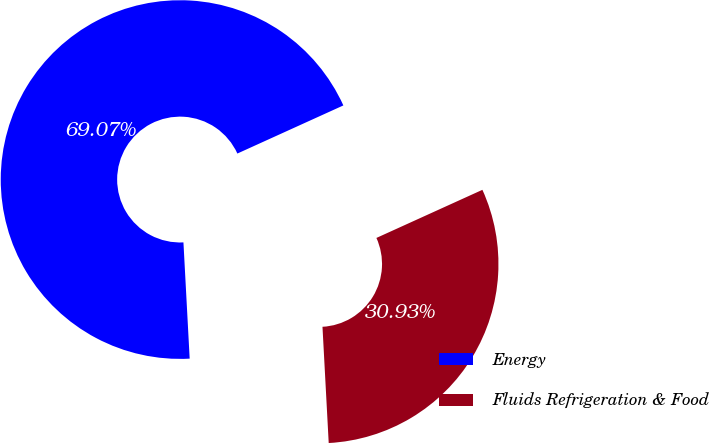Convert chart to OTSL. <chart><loc_0><loc_0><loc_500><loc_500><pie_chart><fcel>Energy<fcel>Fluids Refrigeration & Food<nl><fcel>69.07%<fcel>30.93%<nl></chart> 